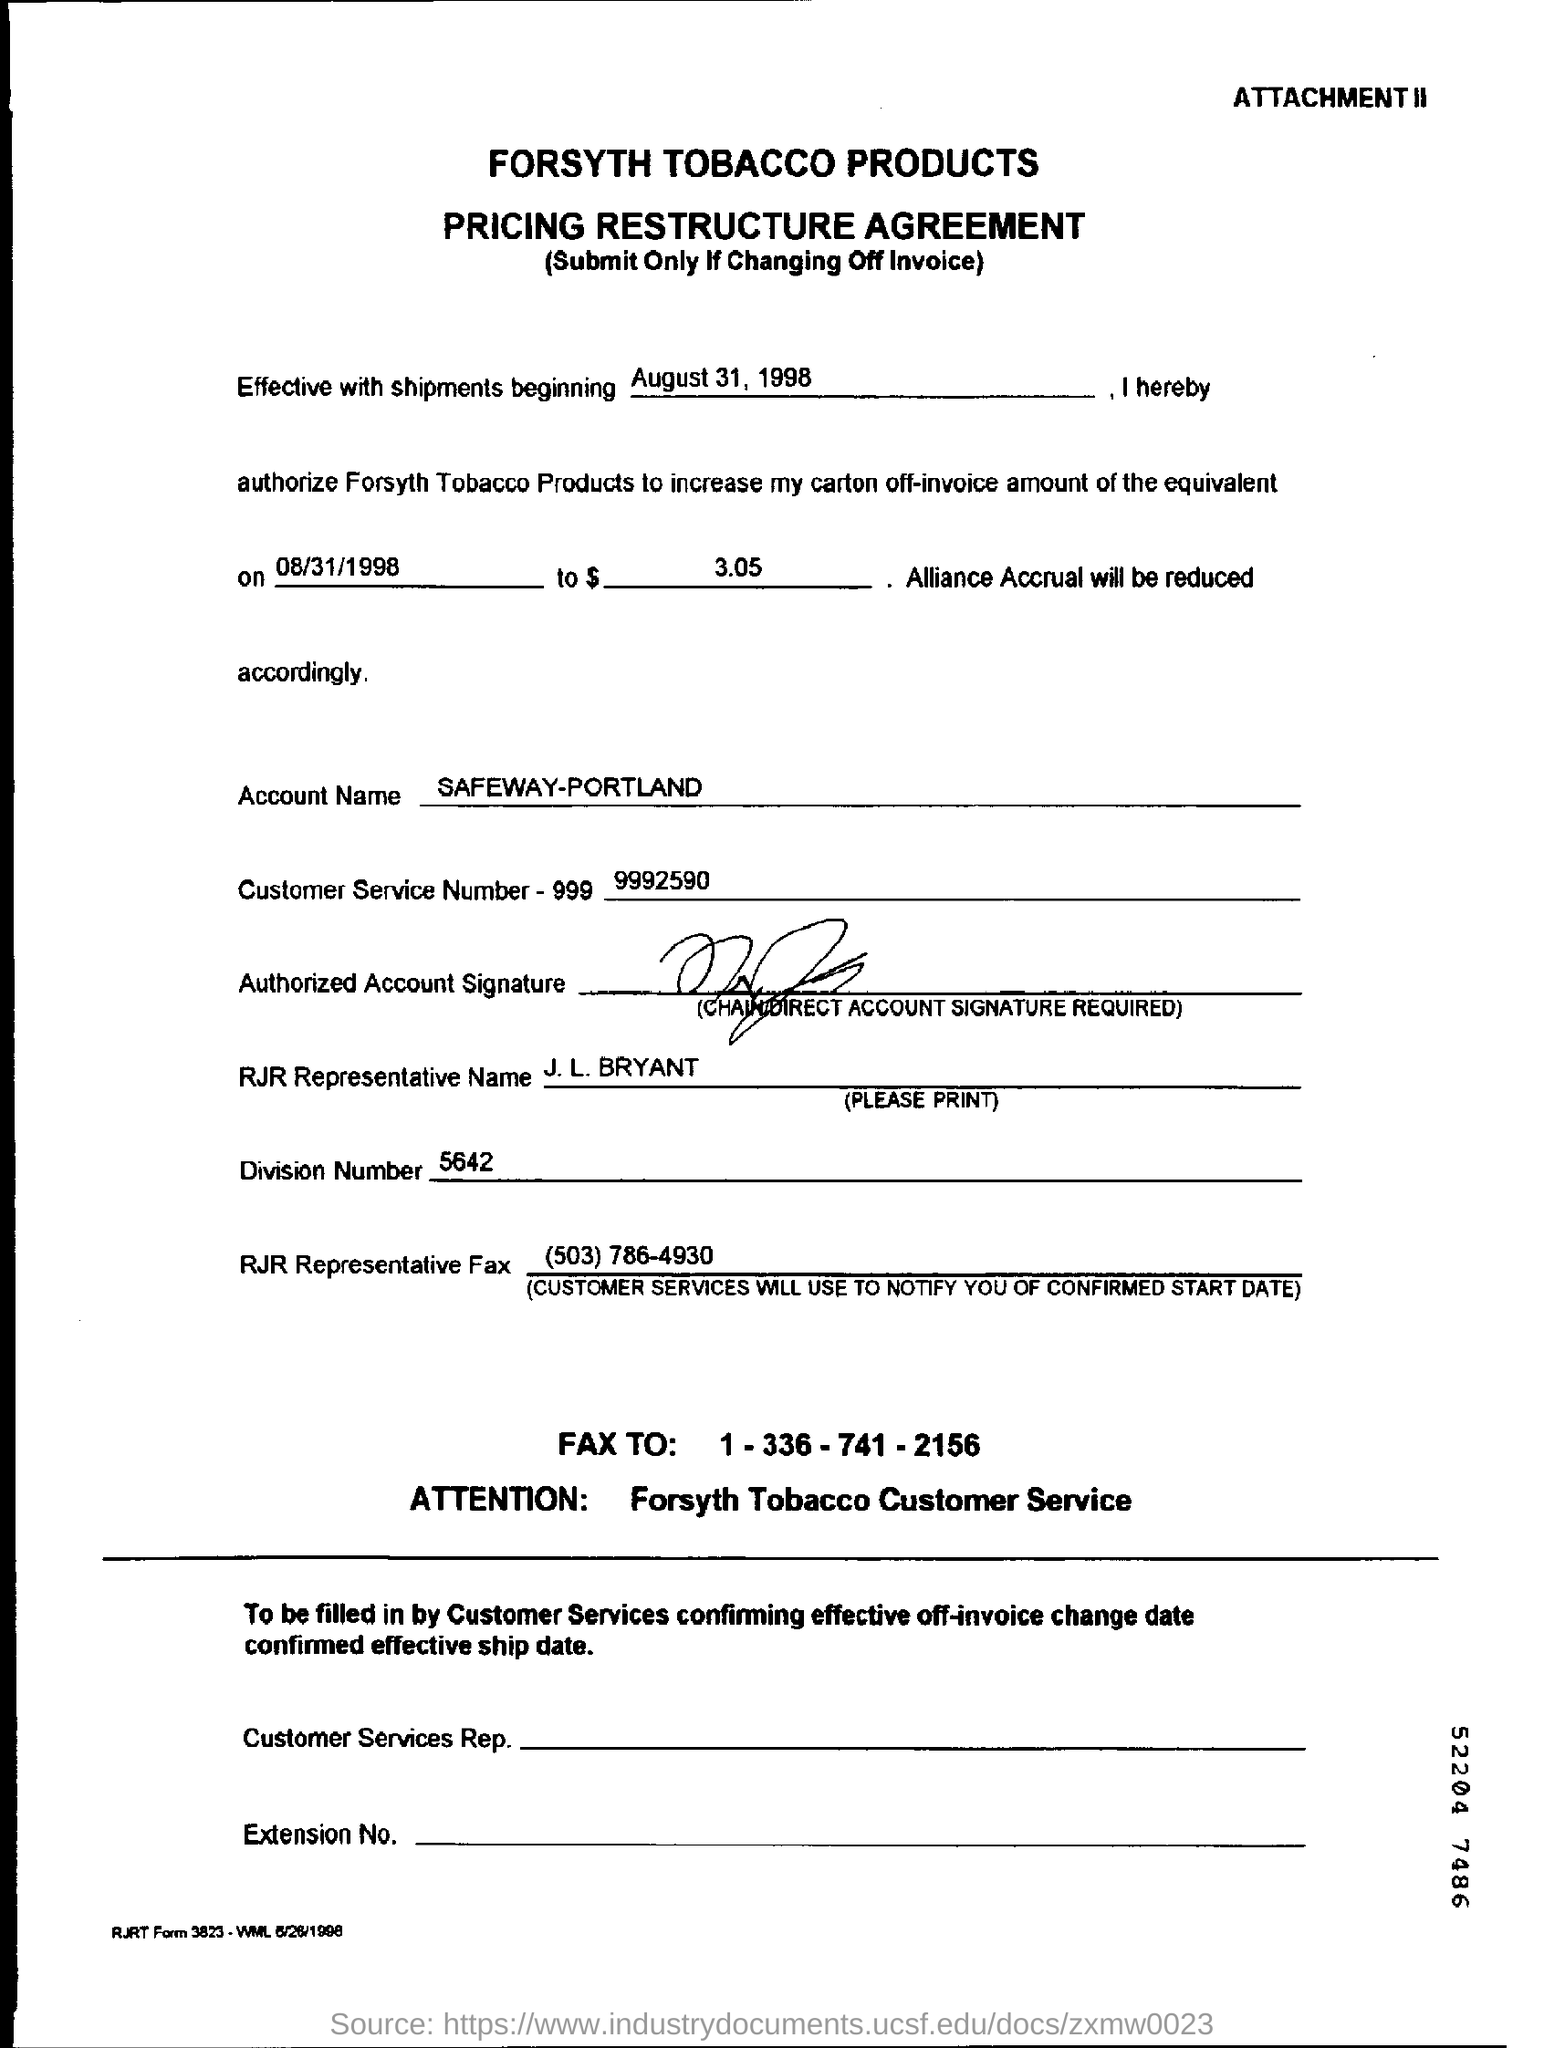Outline some significant characteristics in this image. The account name mentioned in this document is SAFEWAY-PORTLAND. The name of the company is Forsyth Tobacco Products. What is the division number? 5642..." is a question that asks for information about a specific number, specifically the division number. The customer service number is 9992590... J.L. Bryant represented RJR Company. 